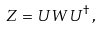<formula> <loc_0><loc_0><loc_500><loc_500>Z = U W U ^ { \dagger } \, ,</formula> 